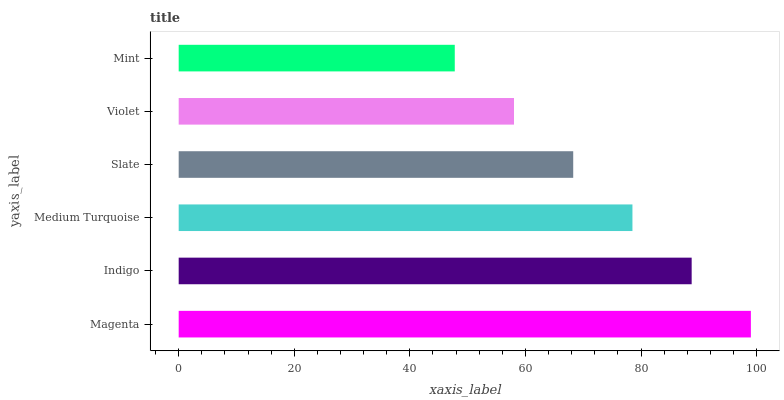Is Mint the minimum?
Answer yes or no. Yes. Is Magenta the maximum?
Answer yes or no. Yes. Is Indigo the minimum?
Answer yes or no. No. Is Indigo the maximum?
Answer yes or no. No. Is Magenta greater than Indigo?
Answer yes or no. Yes. Is Indigo less than Magenta?
Answer yes or no. Yes. Is Indigo greater than Magenta?
Answer yes or no. No. Is Magenta less than Indigo?
Answer yes or no. No. Is Medium Turquoise the high median?
Answer yes or no. Yes. Is Slate the low median?
Answer yes or no. Yes. Is Indigo the high median?
Answer yes or no. No. Is Medium Turquoise the low median?
Answer yes or no. No. 